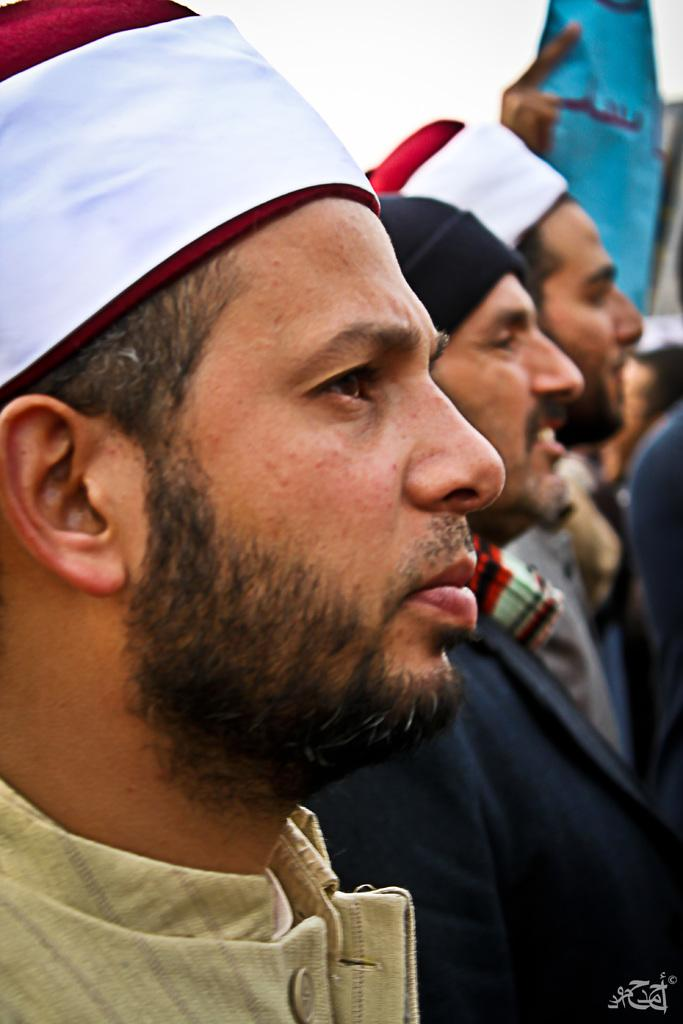What is happening in the center of the image? There are people standing in the center of the image. What are the people wearing on their heads? The people are wearing caps. What type of parcel is being delivered to the people in the image? There is no parcel present in the image. What are the people using to knit in the image? There is no knitting or wool present in the image. 